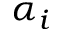<formula> <loc_0><loc_0><loc_500><loc_500>\alpha _ { i }</formula> 